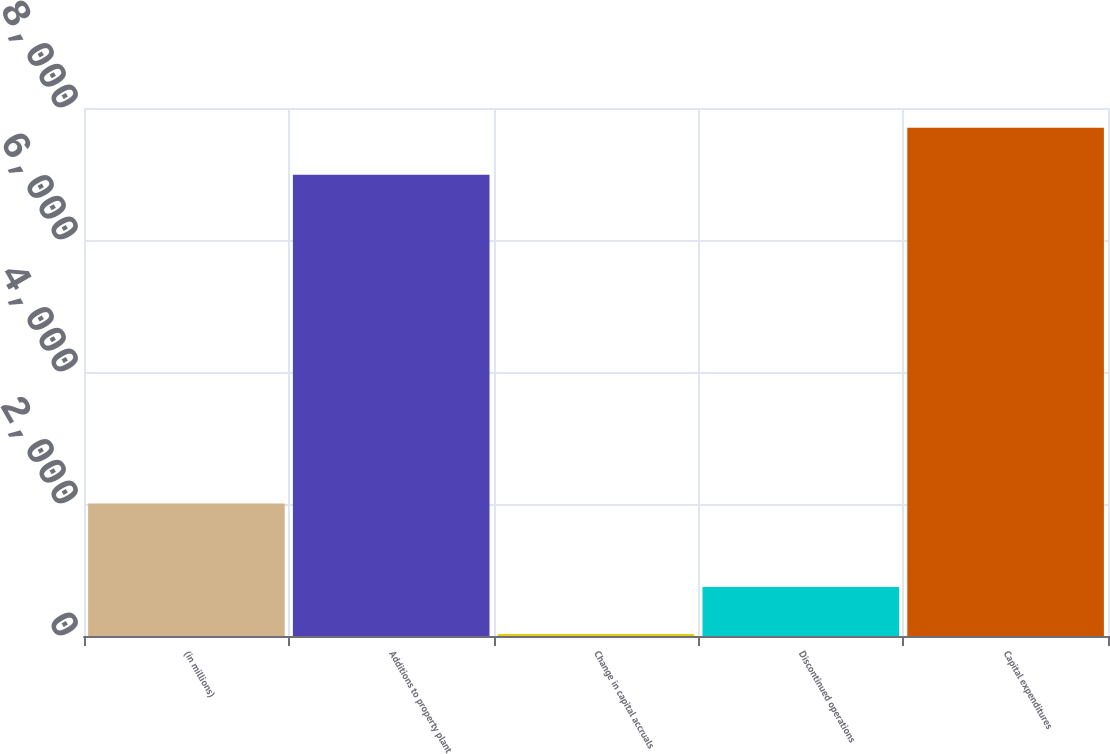Convert chart to OTSL. <chart><loc_0><loc_0><loc_500><loc_500><bar_chart><fcel>(in millions)<fcel>Additions to property plant<fcel>Change in capital accruals<fcel>Discontinued operations<fcel>Capital expenditures<nl><fcel>2008<fcel>6989<fcel>30<fcel>741.6<fcel>7700.6<nl></chart> 